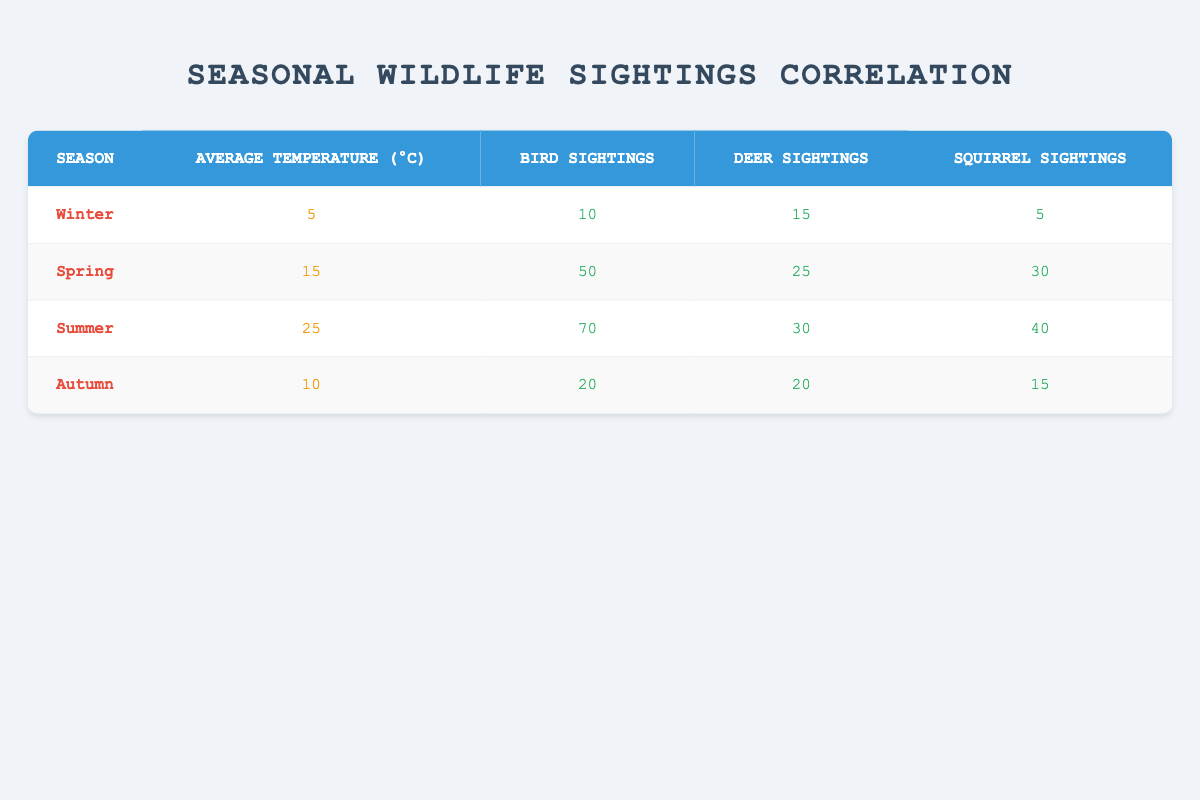What season had the highest number of bird sightings? Looking through the table, Spring has 50 bird sightings, Summer has 70, Winter has 10, and Autumn has 20. Since 70 is the highest number of sightings, Summer is the correct answer.
Answer: Summer In which season do we see an equal number of deer sightings in comparison to squirrel sightings? Examining the table, we see that in Autumn, both deer and squirrel sightings are at 20 and 15, respectively. Spring has 25 and 30, Winter has 15 and 5, while Summer shows 30 and 40. Autumn is thus the only season with equal deer sightings and close numbers for others.
Answer: Autumn What is the total number of wildlife sightings in Winter? To find the total for Winter, we add the bird sightings (10), deer sightings (15), and squirrel sightings (5) together: 10 + 15 + 5 = 30.
Answer: 30 Is there a season where the average temperature was above 20 degrees Celsius? Checking the temperatures for each season, we find Winter at 5, Spring at 15, Summer at 25, and Autumn at 10. Since Summer is the only season surpassing 20 degrees, the answer is yes.
Answer: Yes What is the difference in bird sightings between Summer and Winter? In Summer, there are 70 bird sightings while Winter has 10 sightings. The difference is calculated by subtracting Winter's number from Summer's: 70 - 10 = 60.
Answer: 60 Which season has the lowest average temperature? By reviewing the average temperatures, Winter at 5°C is the lowest compared to Spring (15°C), Summer (25°C), and Autumn (10°C). Therefore, Winter has the lowest average temperature.
Answer: Winter How many total wildlife sightings were recorded in Spring compared to Autumn? For Spring, we have bird (50), deer (25), and squirrel (30) sightings, totaling 50 + 25 + 30 = 105. For Autumn, we have bird (20), deer (20), and squirrel (15) sightings, totaling 20 + 20 + 15 = 55. Comparing these, Spring has 50 more sightings than Autumn (105 - 55).
Answer: 50 Which season has the highest average temperature and the lowest number of squirrel sightings? Summer has the highest average temperature at 25°C, while in Winter, there are only 5 squirrel sightings, which is the lowest among all seasons (Summer 40, Spring 30, Autumn 15). Thus, Winter has the lowest squirrel sightings.
Answer: Winter 